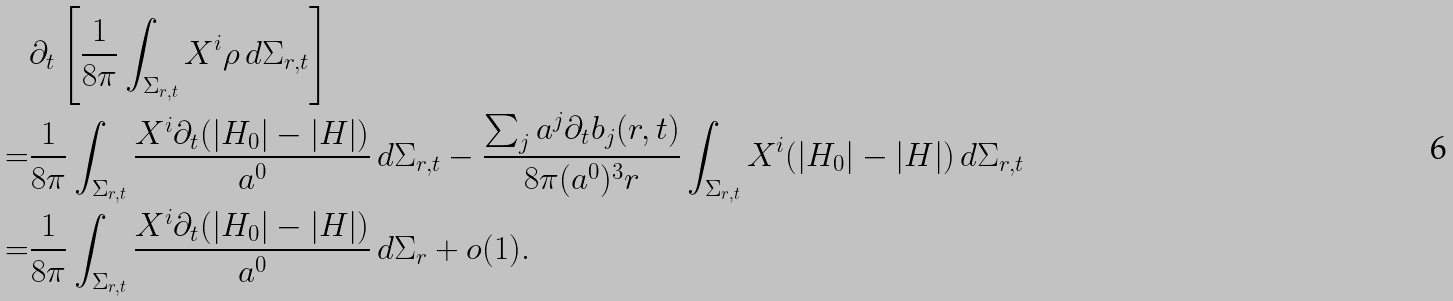Convert formula to latex. <formula><loc_0><loc_0><loc_500><loc_500>& \partial _ { t } \left [ \frac { 1 } { 8 \pi } \int _ { \Sigma _ { r , t } } X ^ { i } \rho \, d \Sigma _ { r , t } \right ] \\ = & \frac { 1 } { 8 \pi } \int _ { \Sigma _ { r , t } } \frac { X ^ { i } \partial _ { t } ( | H _ { 0 } | - | H | ) } { a ^ { 0 } } \, d \Sigma _ { r , t } - \frac { \sum _ { j } a ^ { j } \partial _ { t } b _ { j } ( r , t ) } { 8 \pi ( a ^ { 0 } ) ^ { 3 } r } \int _ { \Sigma _ { r , t } } X ^ { i } ( | H _ { 0 } | - | H | ) \, d \Sigma _ { r , t } \\ = & \frac { 1 } { 8 \pi } \int _ { \Sigma _ { r , t } } \frac { X ^ { i } \partial _ { t } ( | H _ { 0 } | - | H | ) } { a ^ { 0 } } \, d \Sigma _ { r } + o ( 1 ) .</formula> 